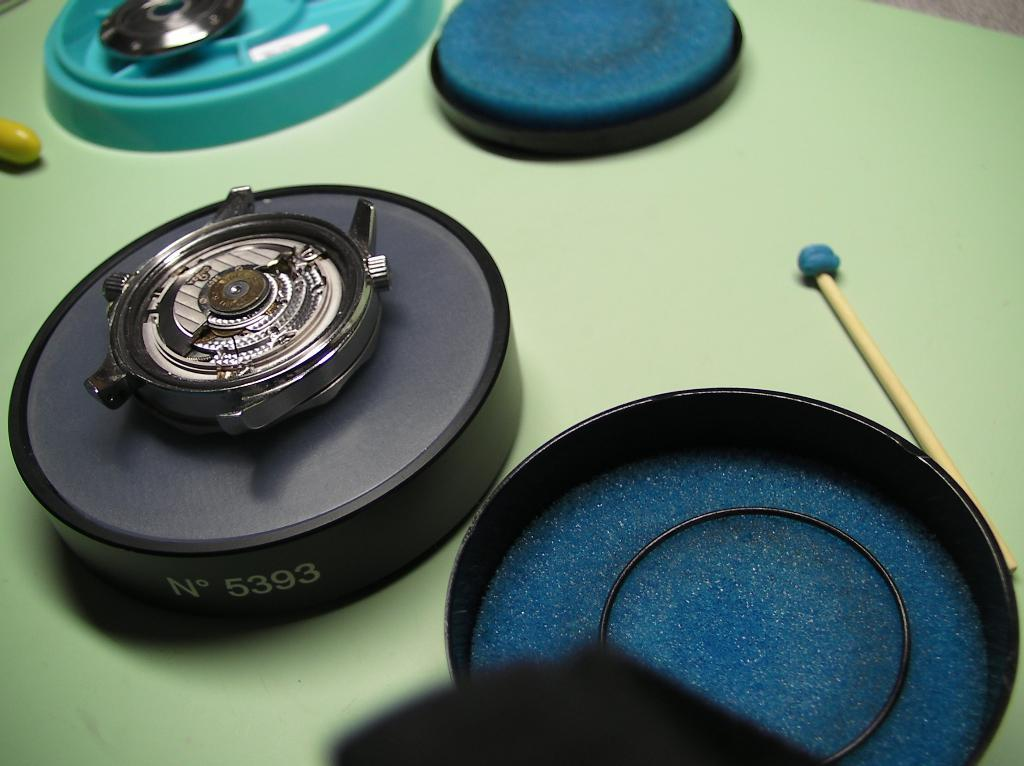<image>
Summarize the visual content of the image. A mechanical device with the number 5393 on the side sitting on a green surface. 